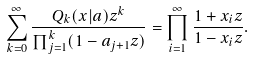<formula> <loc_0><loc_0><loc_500><loc_500>\sum _ { k = 0 } ^ { \infty } \frac { Q _ { k } ( x | a ) z ^ { k } } { \prod _ { j = 1 } ^ { k } ( 1 - a _ { j + 1 } z ) } = \prod _ { i = 1 } ^ { \infty } \frac { 1 + x _ { i } z } { 1 - x _ { i } z } .</formula> 